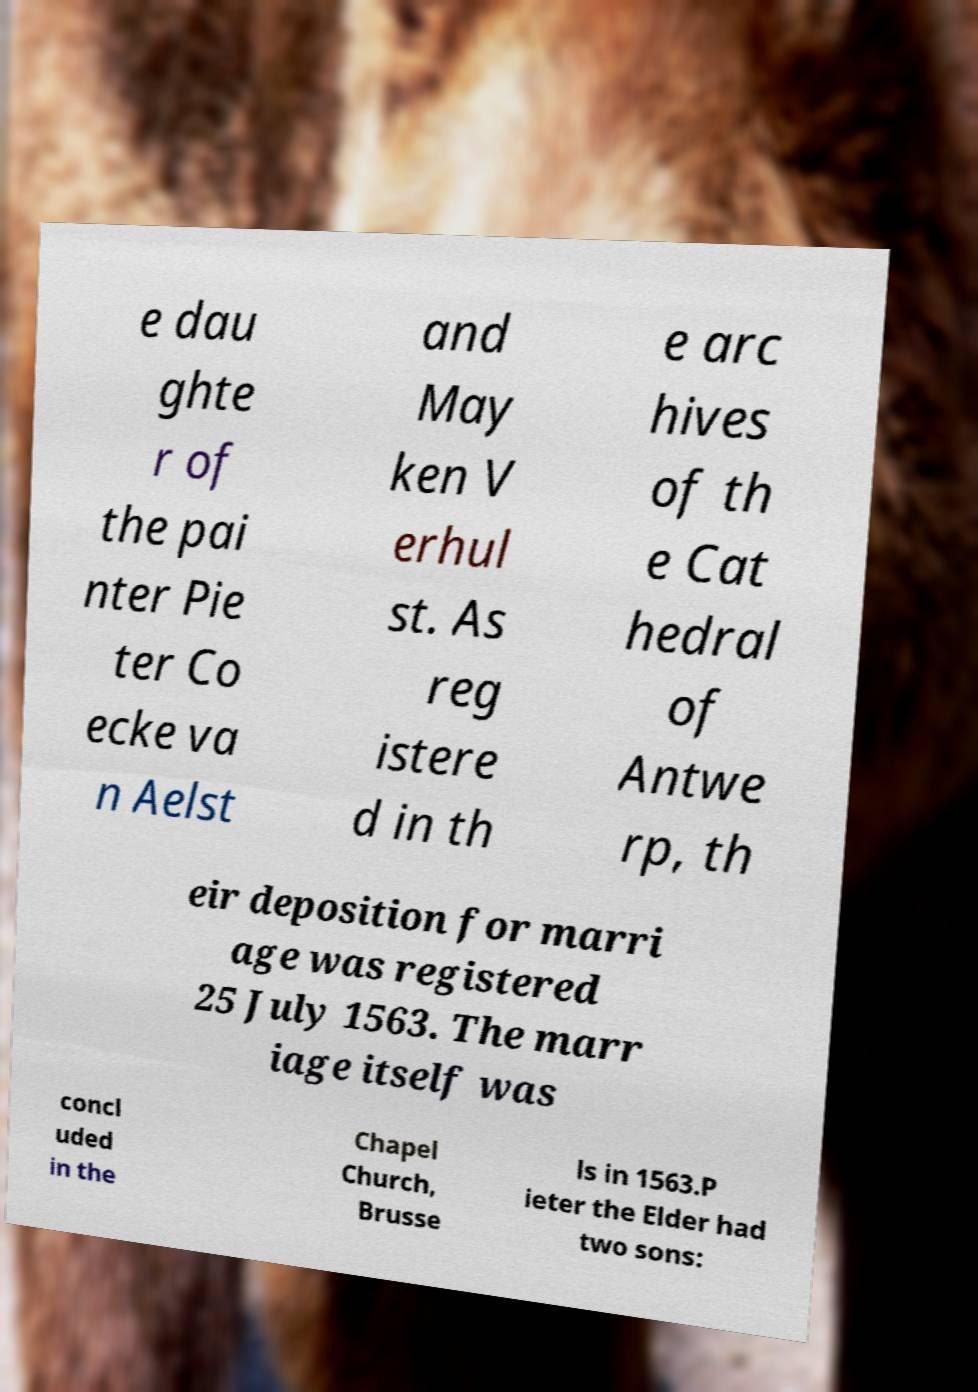What messages or text are displayed in this image? I need them in a readable, typed format. e dau ghte r of the pai nter Pie ter Co ecke va n Aelst and May ken V erhul st. As reg istere d in th e arc hives of th e Cat hedral of Antwe rp, th eir deposition for marri age was registered 25 July 1563. The marr iage itself was concl uded in the Chapel Church, Brusse ls in 1563.P ieter the Elder had two sons: 